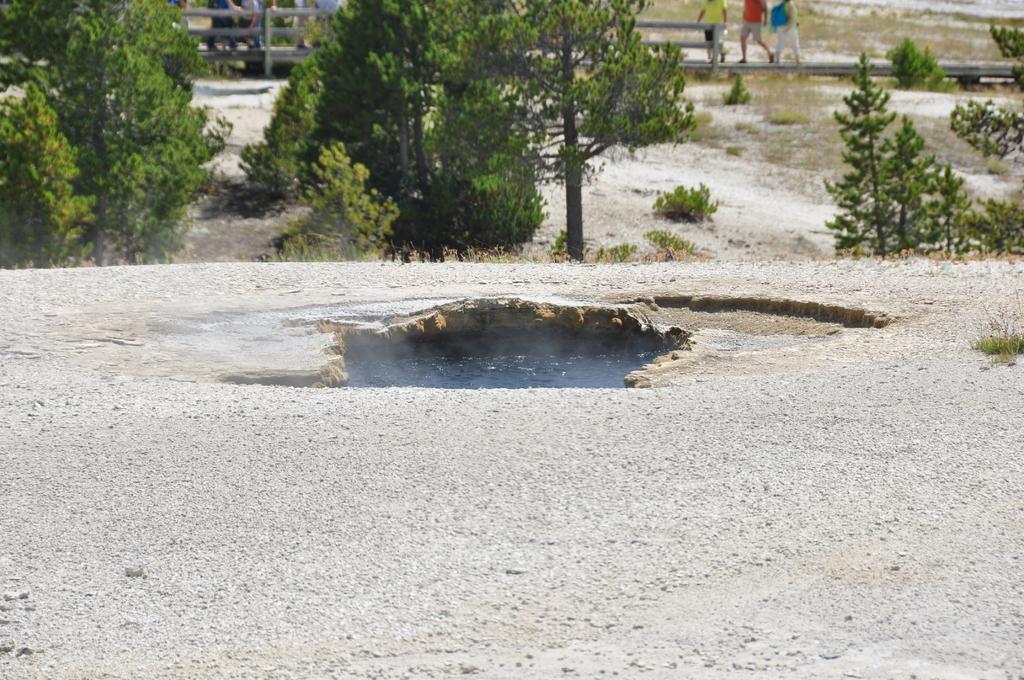In one or two sentences, can you explain what this image depicts? In the image we can see some stones. Top of the image there are some trees. Behind the trees there is a fencing. Behind the fencing few people are walking. 